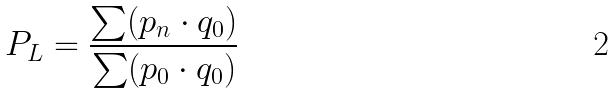<formula> <loc_0><loc_0><loc_500><loc_500>P _ { L } = \frac { \sum ( p _ { n } \cdot q _ { 0 } ) } { \sum ( p _ { 0 } \cdot q _ { 0 } ) }</formula> 